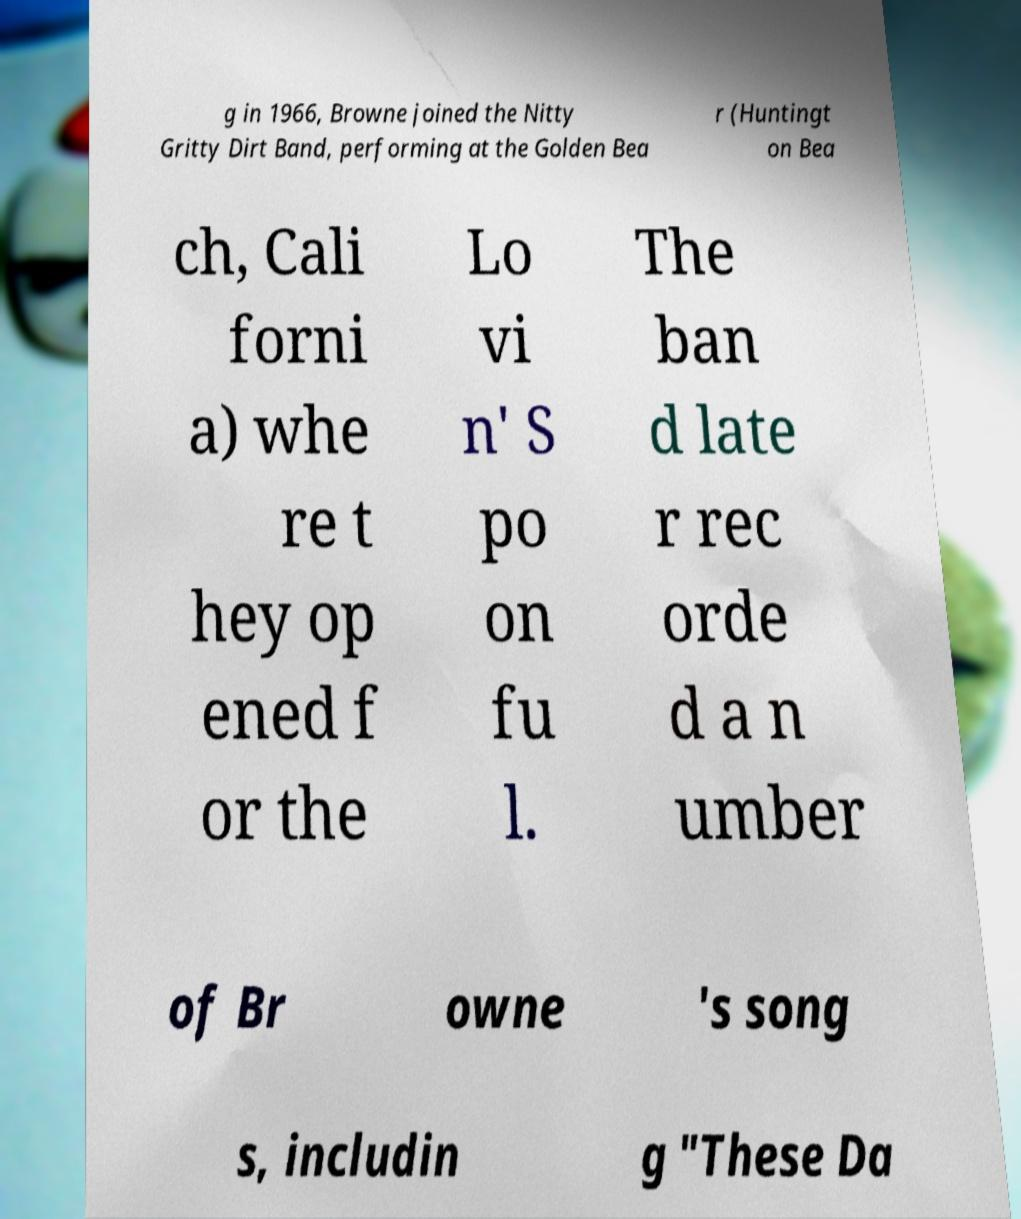Can you read and provide the text displayed in the image?This photo seems to have some interesting text. Can you extract and type it out for me? g in 1966, Browne joined the Nitty Gritty Dirt Band, performing at the Golden Bea r (Huntingt on Bea ch, Cali forni a) whe re t hey op ened f or the Lo vi n' S po on fu l. The ban d late r rec orde d a n umber of Br owne 's song s, includin g "These Da 